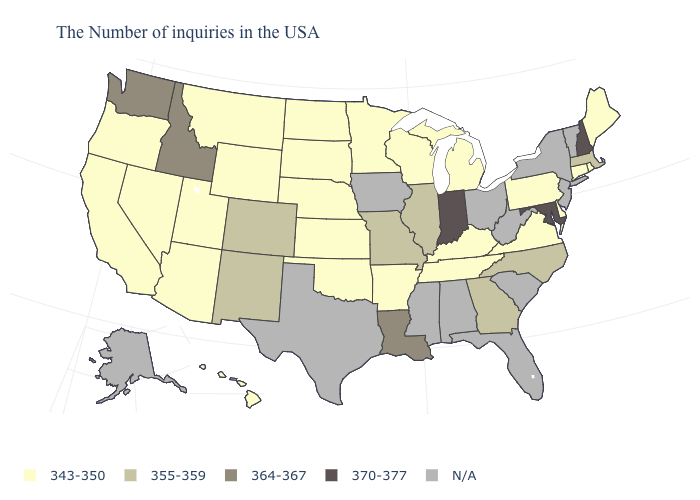Does Oklahoma have the lowest value in the South?
Keep it brief. Yes. What is the value of Montana?
Short answer required. 343-350. Which states have the lowest value in the West?
Write a very short answer. Wyoming, Utah, Montana, Arizona, Nevada, California, Oregon, Hawaii. What is the value of Oklahoma?
Answer briefly. 343-350. Which states hav the highest value in the Northeast?
Keep it brief. New Hampshire. Name the states that have a value in the range 364-367?
Write a very short answer. Louisiana, Idaho, Washington. Does Kentucky have the lowest value in the South?
Answer briefly. Yes. What is the highest value in the USA?
Keep it brief. 370-377. What is the value of Rhode Island?
Answer briefly. 343-350. Which states hav the highest value in the MidWest?
Short answer required. Indiana. What is the value of Delaware?
Short answer required. 343-350. Name the states that have a value in the range 364-367?
Give a very brief answer. Louisiana, Idaho, Washington. What is the value of Nebraska?
Give a very brief answer. 343-350. What is the value of Idaho?
Concise answer only. 364-367. 